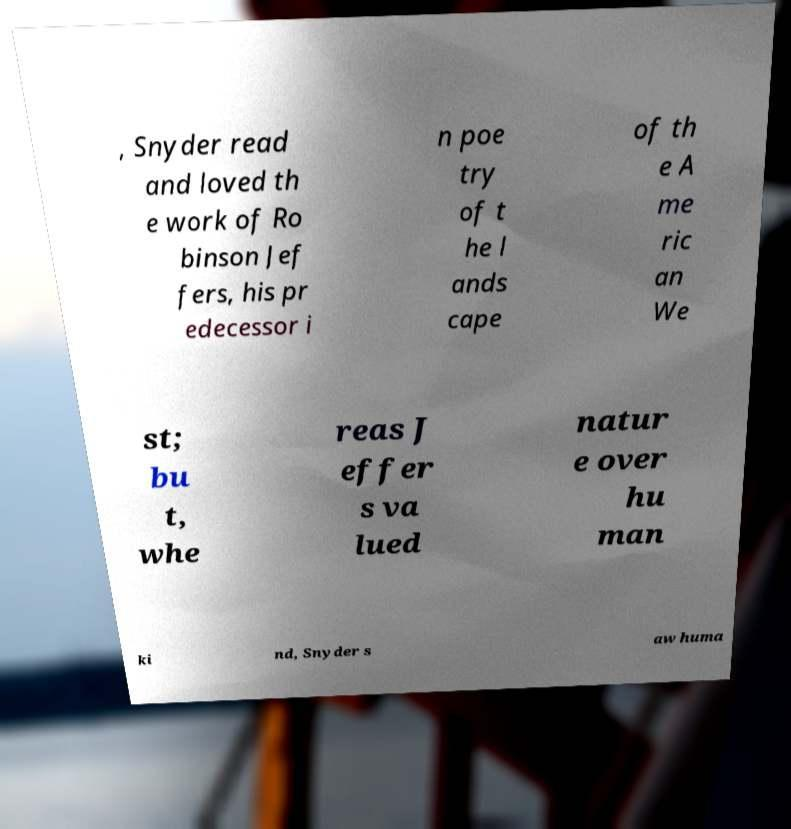For documentation purposes, I need the text within this image transcribed. Could you provide that? , Snyder read and loved th e work of Ro binson Jef fers, his pr edecessor i n poe try of t he l ands cape of th e A me ric an We st; bu t, whe reas J effer s va lued natur e over hu man ki nd, Snyder s aw huma 